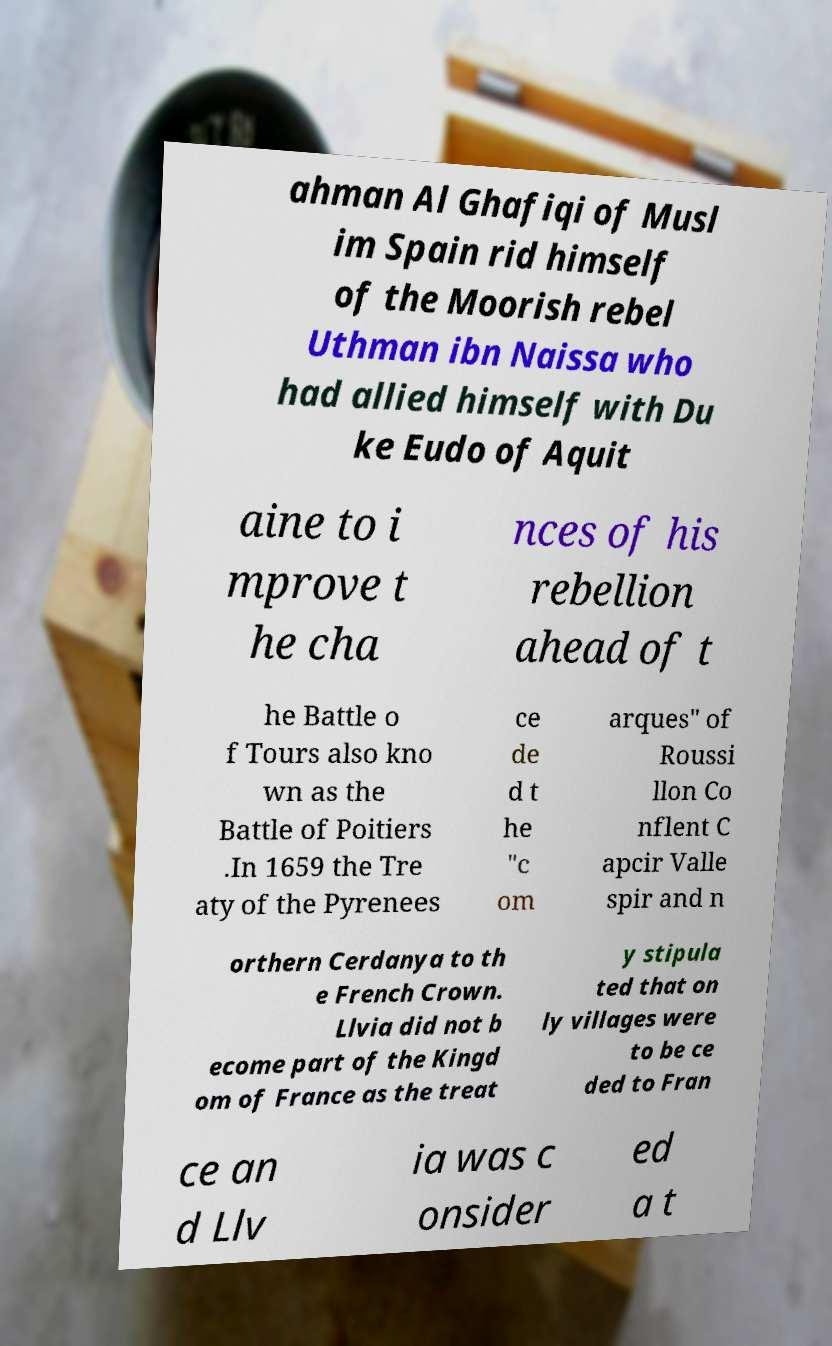Could you extract and type out the text from this image? ahman Al Ghafiqi of Musl im Spain rid himself of the Moorish rebel Uthman ibn Naissa who had allied himself with Du ke Eudo of Aquit aine to i mprove t he cha nces of his rebellion ahead of t he Battle o f Tours also kno wn as the Battle of Poitiers .In 1659 the Tre aty of the Pyrenees ce de d t he "c om arques" of Roussi llon Co nflent C apcir Valle spir and n orthern Cerdanya to th e French Crown. Llvia did not b ecome part of the Kingd om of France as the treat y stipula ted that on ly villages were to be ce ded to Fran ce an d Llv ia was c onsider ed a t 